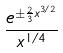<formula> <loc_0><loc_0><loc_500><loc_500>\frac { e ^ { \pm \frac { 2 } { 3 } x ^ { 3 / 2 } } } { x ^ { 1 / 4 } }</formula> 